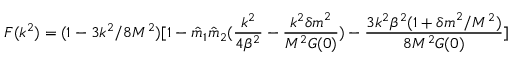Convert formula to latex. <formula><loc_0><loc_0><loc_500><loc_500>F ( k ^ { 2 } ) = ( 1 - 3 k ^ { 2 } / 8 M ^ { 2 } ) [ 1 - { \hat { m } } _ { 1 } { \hat { m } } _ { 2 } ( { \frac { k ^ { 2 } } { 4 \beta ^ { 2 } } } - { \frac { k ^ { 2 } { \delta m } ^ { 2 } } { M ^ { 2 } G ( 0 ) } } ) - { \frac { 3 k ^ { 2 } \beta ^ { 2 } ( 1 + { \delta m } ^ { 2 } / M ^ { 2 } ) } { 8 M ^ { 2 } G ( 0 ) } } ]</formula> 